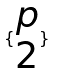<formula> <loc_0><loc_0><loc_500><loc_500>\{ \begin{matrix} p \\ 2 \end{matrix} \}</formula> 